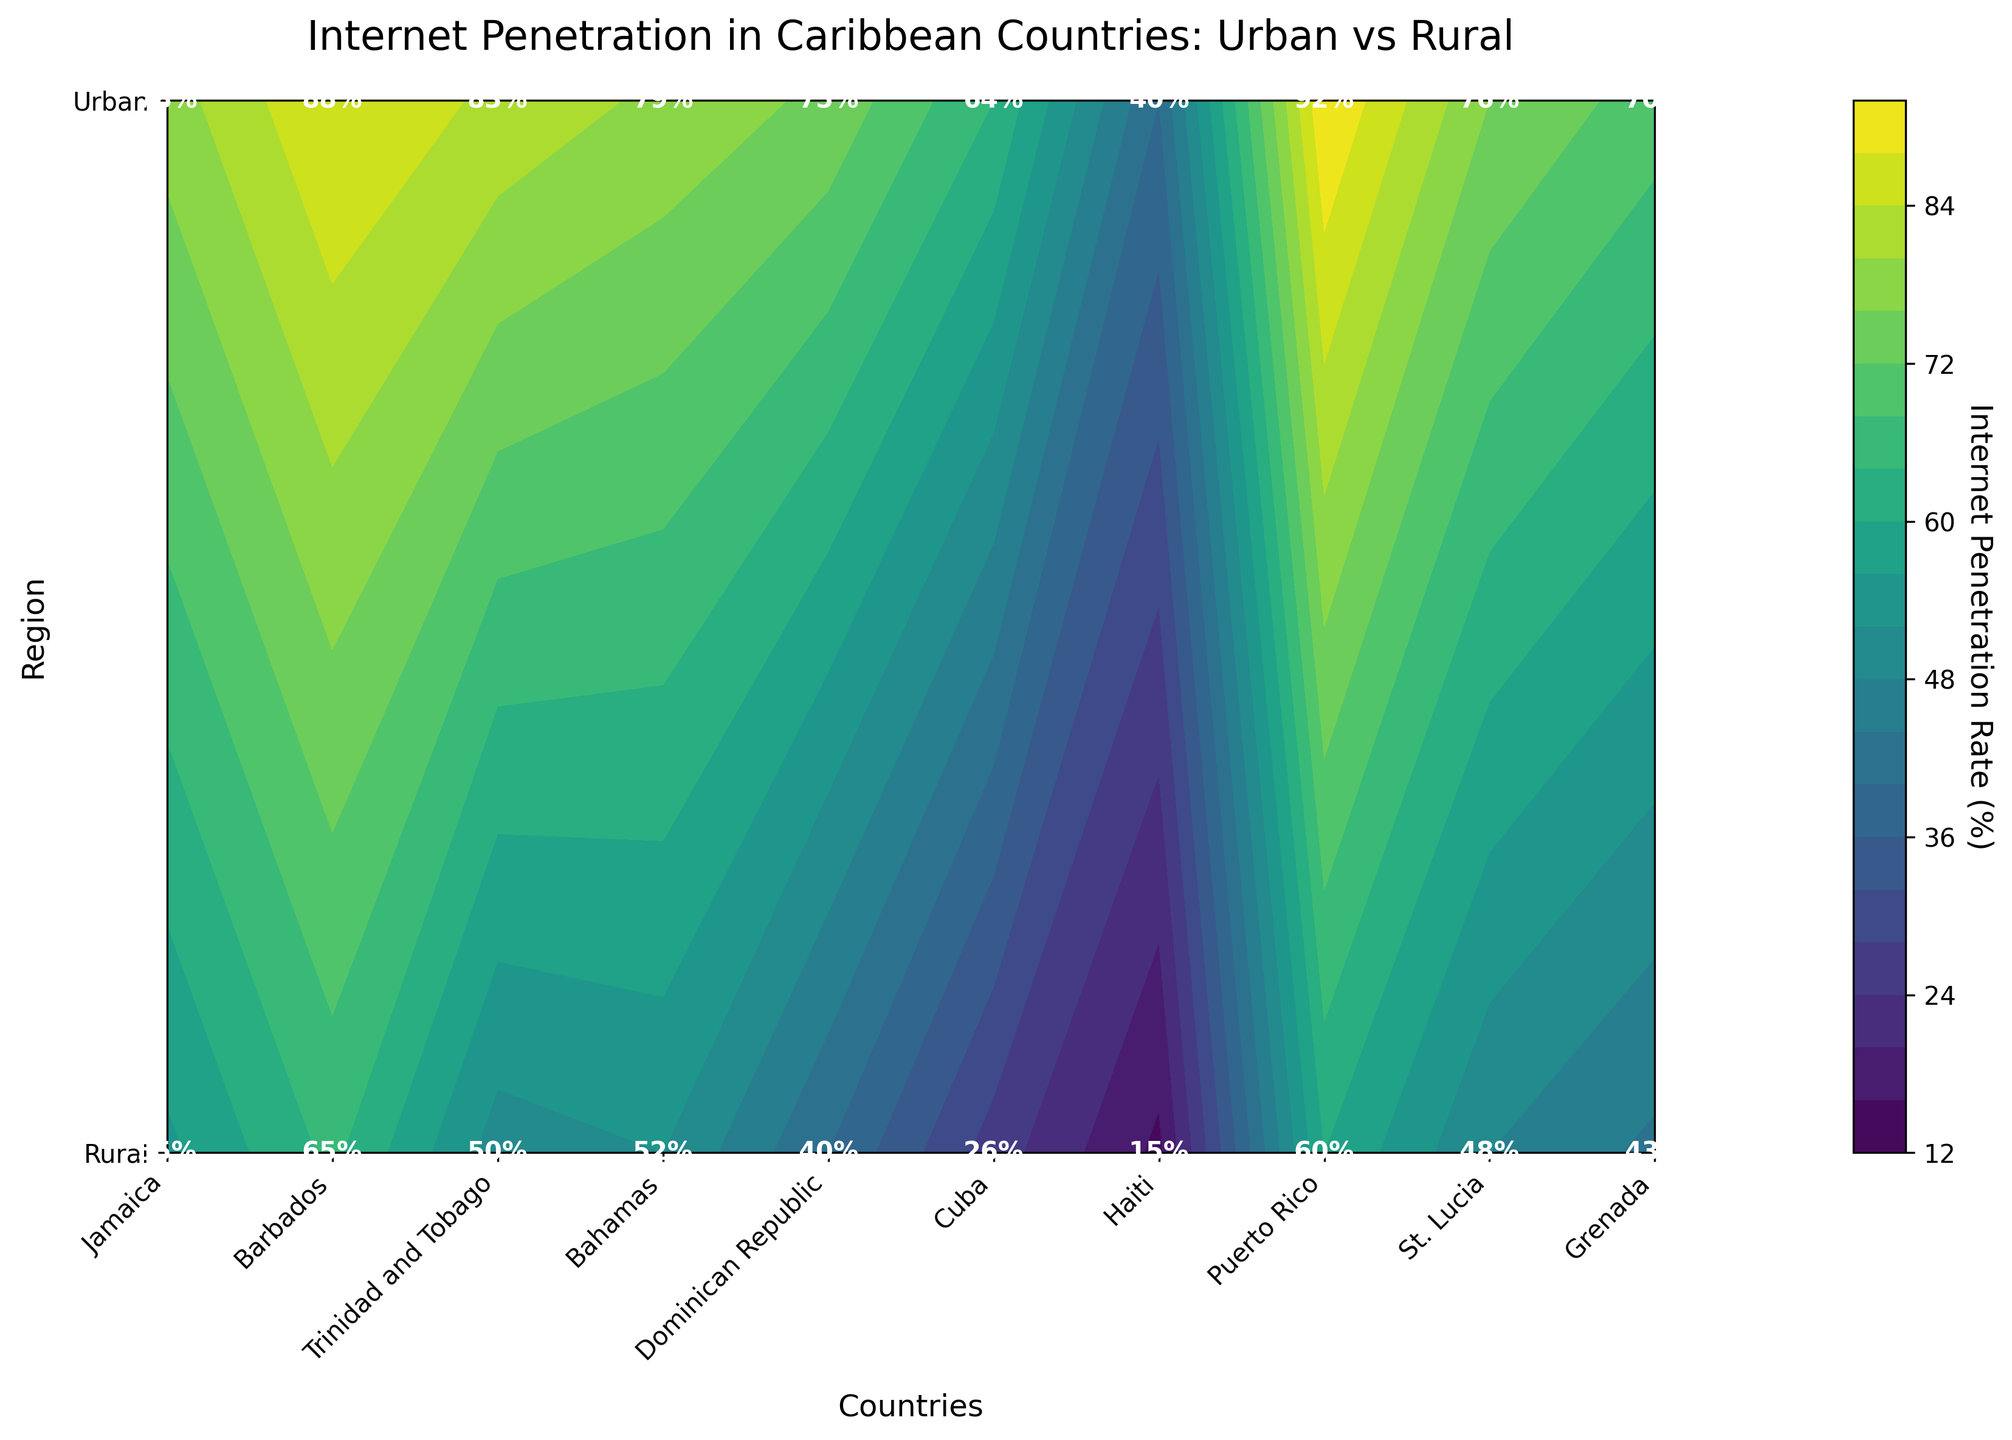What is the internet penetration rate in Urban areas of Puerto Rico? Look at the value indicated within the Urban region for Puerto Rico. The text inside the box labeled '1' (Urban) for Puerto Rico shows the rate.
Answer: 92% What is the title of the figure? The title is stated at the top of the figure in larger and bold text.
Answer: Internet Penetration in Caribbean Countries: Urban vs Rural How does the internet penetration rate in Urban areas of Jamaica compare to Rural areas of Jamaica? Compare the values given in the Urban and Rural regions for Jamaica. For Urban, it is 78%, and for Rural, it is 55%.
Answer: Urban 78%, Rural 55% Which country has the lowest rural internet penetration rate? Identify the smallest value in the Rural row of the figure. The lowest value is 15% for Haiti.
Answer: Haiti What is the average internet penetration rate in Urban areas among all listed countries? Sum the urban penetration rates [(78 + 88 + 83 + 79 + 75 + 64 + 40 + 92 + 76 + 70)=745], then divide by the number of countries (10). 745/10 = 74.5%
Answer: 74.5% What is the difference in internet penetration rates between Urban and Rural areas in Cuba? Find the values for Cuba in both the Urban and Rural areas. Urban is 64%, and Rural is 26%. Subtract Rural from Urban: 64% - 26% = 38%.
Answer: 38% Which country has the highest discrepancy between Urban and Rural internet penetration rates? Calculate the difference between Urban and Rural rates for each country and compare them. Haiti has the highest discrepancy (40% - 15% = 25%).
Answer: Haiti Are Rural areas generally having lower internet penetration rates compared to Urban areas? Review the entire chart comparing Urban and Rural rates for each country. In all cases, Rural areas have lower rates than their Urban counterparts.
Answer: Yes Which Caribbean country's Urban area's internet penetration rate is closest to the overall Urban average? Compare each Urban rate to the average calculated previously (74.5%). Saint Lucia's Urban rate of 76% is closest to 74.5%.
Answer: St. Lucia What patterns can you see in terms of Internet Penetration between different countries? Analyze the visual pattern distinguishing between Urban and Rural rates and observe general trends. Urban areas consistently have higher internet penetration rates than Rural areas across all Caribbean countries listed.
Answer: Urban higher than Rural across countries 